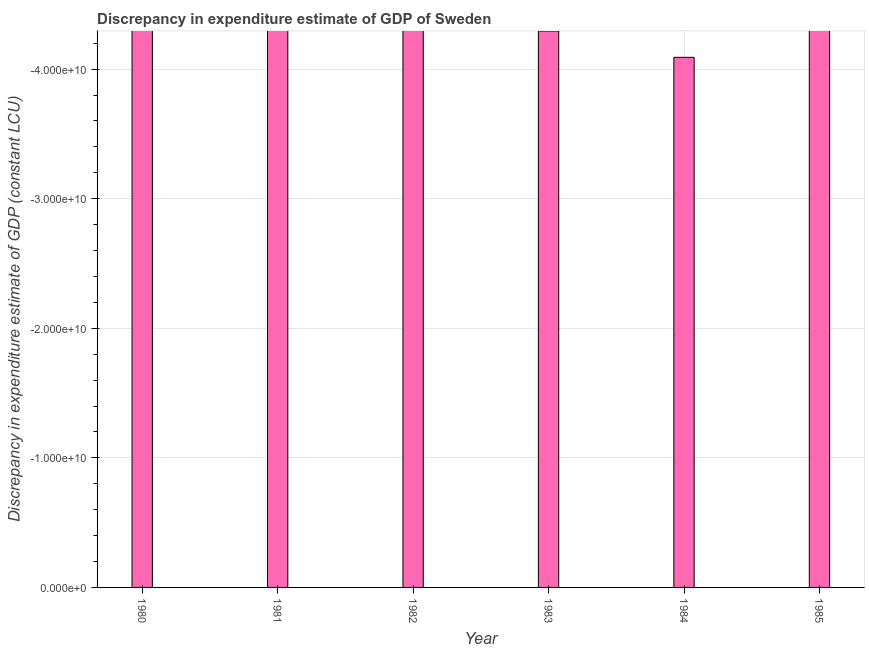Does the graph contain grids?
Offer a very short reply. Yes. What is the title of the graph?
Offer a terse response. Discrepancy in expenditure estimate of GDP of Sweden. What is the label or title of the X-axis?
Offer a terse response. Year. What is the label or title of the Y-axis?
Offer a terse response. Discrepancy in expenditure estimate of GDP (constant LCU). What is the discrepancy in expenditure estimate of gdp in 1982?
Give a very brief answer. 0. What is the median discrepancy in expenditure estimate of gdp?
Give a very brief answer. 0. In how many years, is the discrepancy in expenditure estimate of gdp greater than -36000000000 LCU?
Your answer should be compact. 0. How many bars are there?
Offer a very short reply. 0. How many years are there in the graph?
Your answer should be very brief. 6. Are the values on the major ticks of Y-axis written in scientific E-notation?
Provide a short and direct response. Yes. What is the Discrepancy in expenditure estimate of GDP (constant LCU) of 1980?
Make the answer very short. 0. What is the Discrepancy in expenditure estimate of GDP (constant LCU) of 1981?
Keep it short and to the point. 0. What is the Discrepancy in expenditure estimate of GDP (constant LCU) of 1985?
Give a very brief answer. 0. 